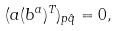<formula> <loc_0><loc_0><loc_500><loc_500>( a ( b ^ { a } ) ^ { T } ) _ { p \hat { q } } = 0 ,</formula> 